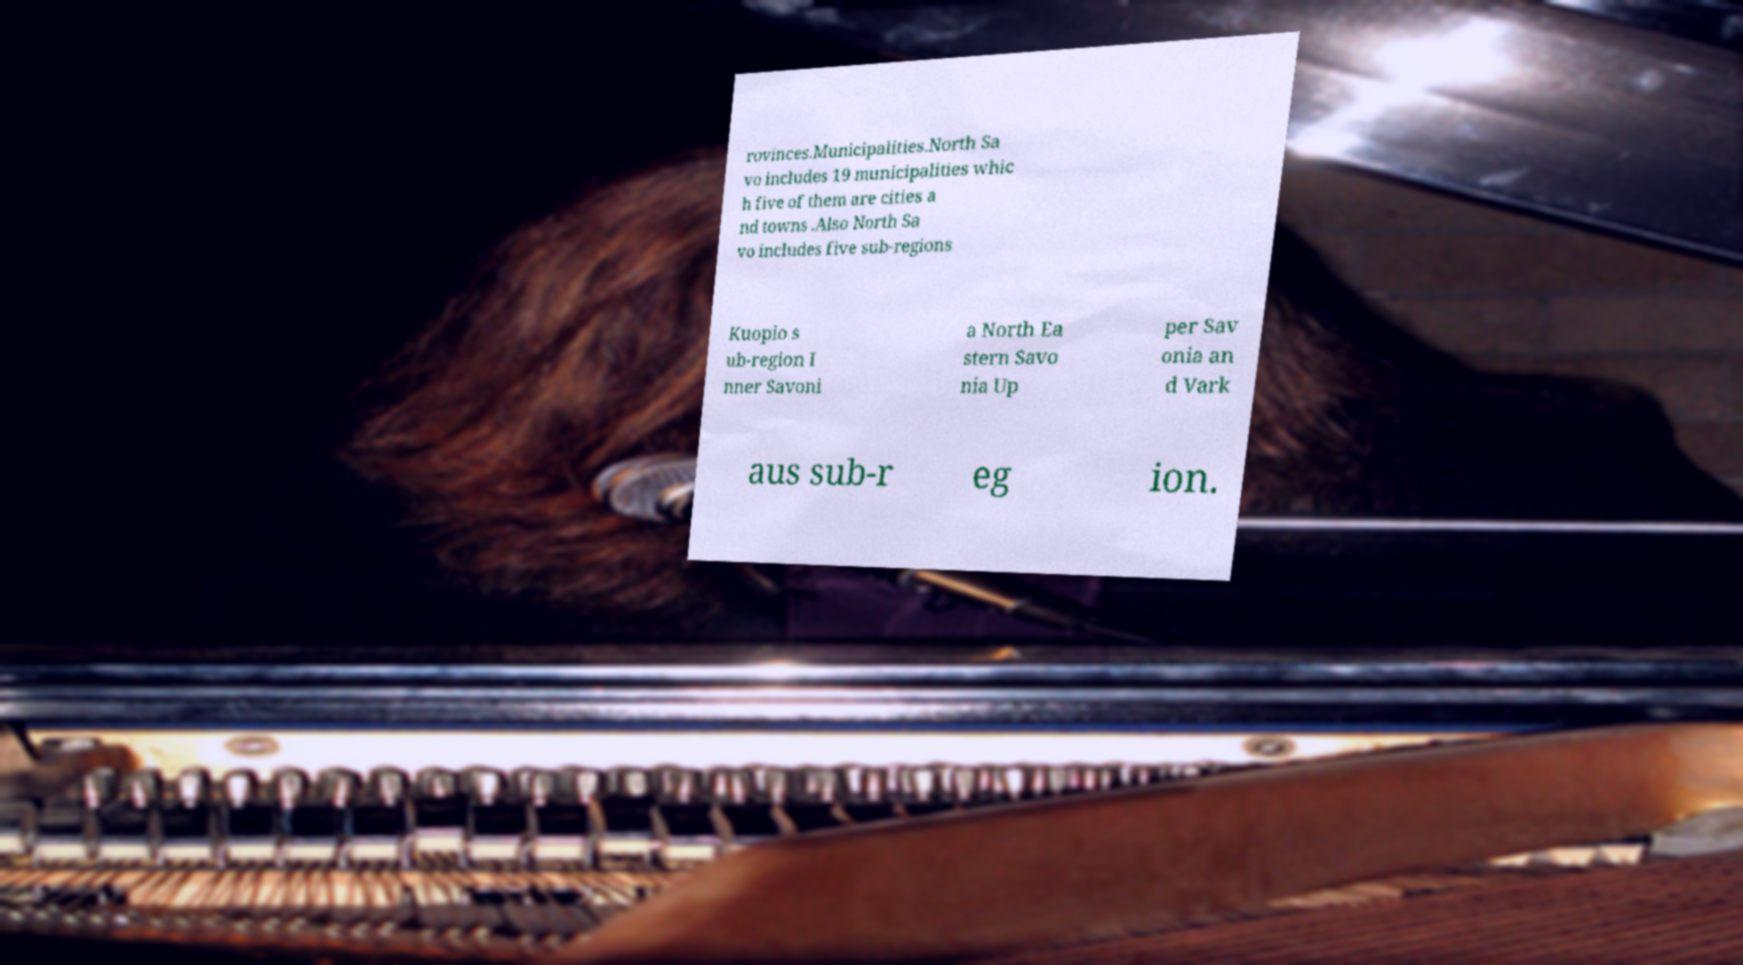I need the written content from this picture converted into text. Can you do that? rovinces.Municipalities.North Sa vo includes 19 municipalities whic h five of them are cities a nd towns .Also North Sa vo includes five sub-regions Kuopio s ub-region I nner Savoni a North Ea stern Savo nia Up per Sav onia an d Vark aus sub-r eg ion. 